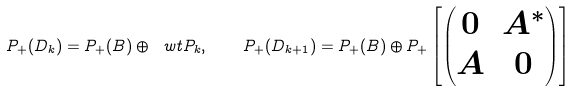Convert formula to latex. <formula><loc_0><loc_0><loc_500><loc_500>P _ { + } ( D _ { k } ) = P _ { + } ( B ) \oplus \ w t P _ { k } , \quad P _ { + } ( D _ { k + 1 } ) = P _ { + } ( B ) \oplus P _ { + } \left [ \begin{pmatrix} 0 & A ^ { * } \\ A & 0 \\ \end{pmatrix} \right ]</formula> 